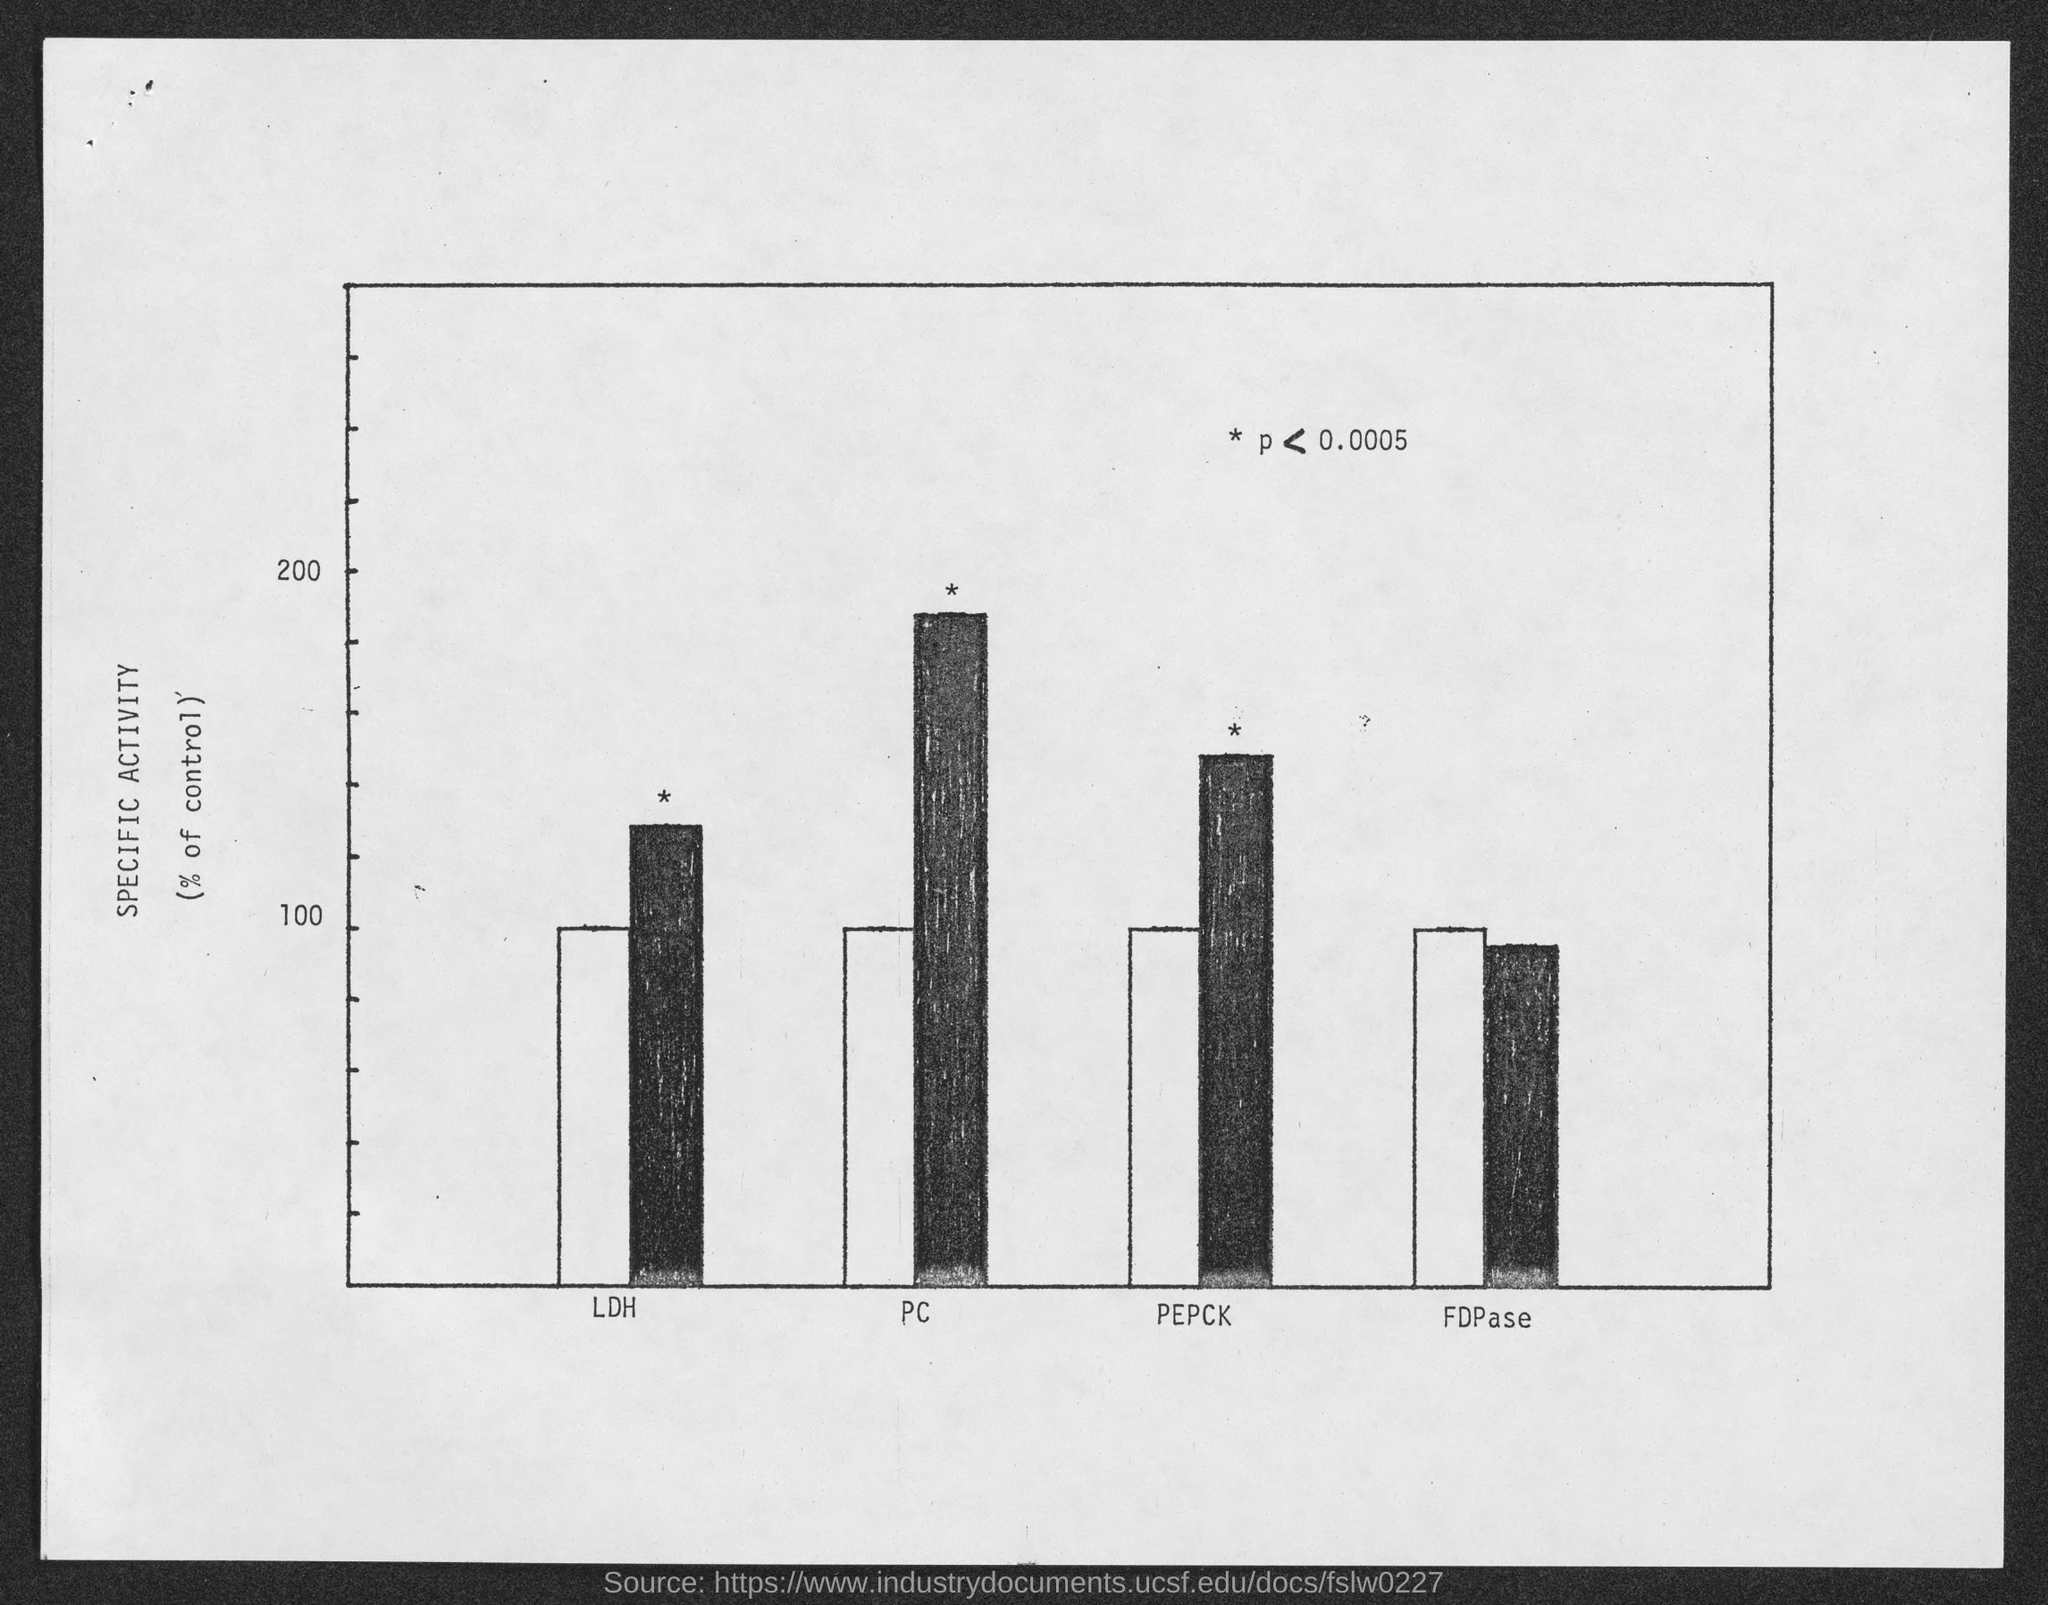Draw attention to some important aspects in this diagram. The highest value written on the Y axis of the graph is 200. The third word written in the X axis is 'PEPCK.' The last word written in the X axis is FDPase. The lowest value written on the Y axis of the graph is 100. The first word written in the X axis is LDH. 